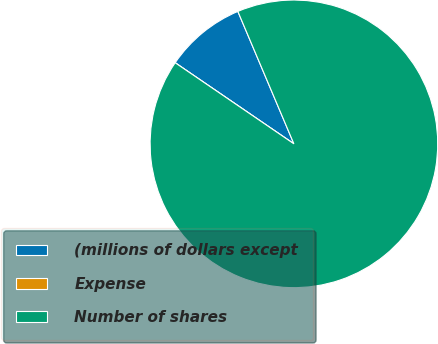Convert chart to OTSL. <chart><loc_0><loc_0><loc_500><loc_500><pie_chart><fcel>(millions of dollars except<fcel>Expense<fcel>Number of shares<nl><fcel>9.09%<fcel>0.0%<fcel>90.91%<nl></chart> 